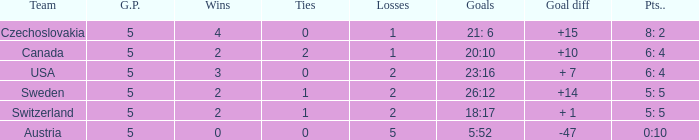What was the largest tie when the G.P was more than 5? None. 